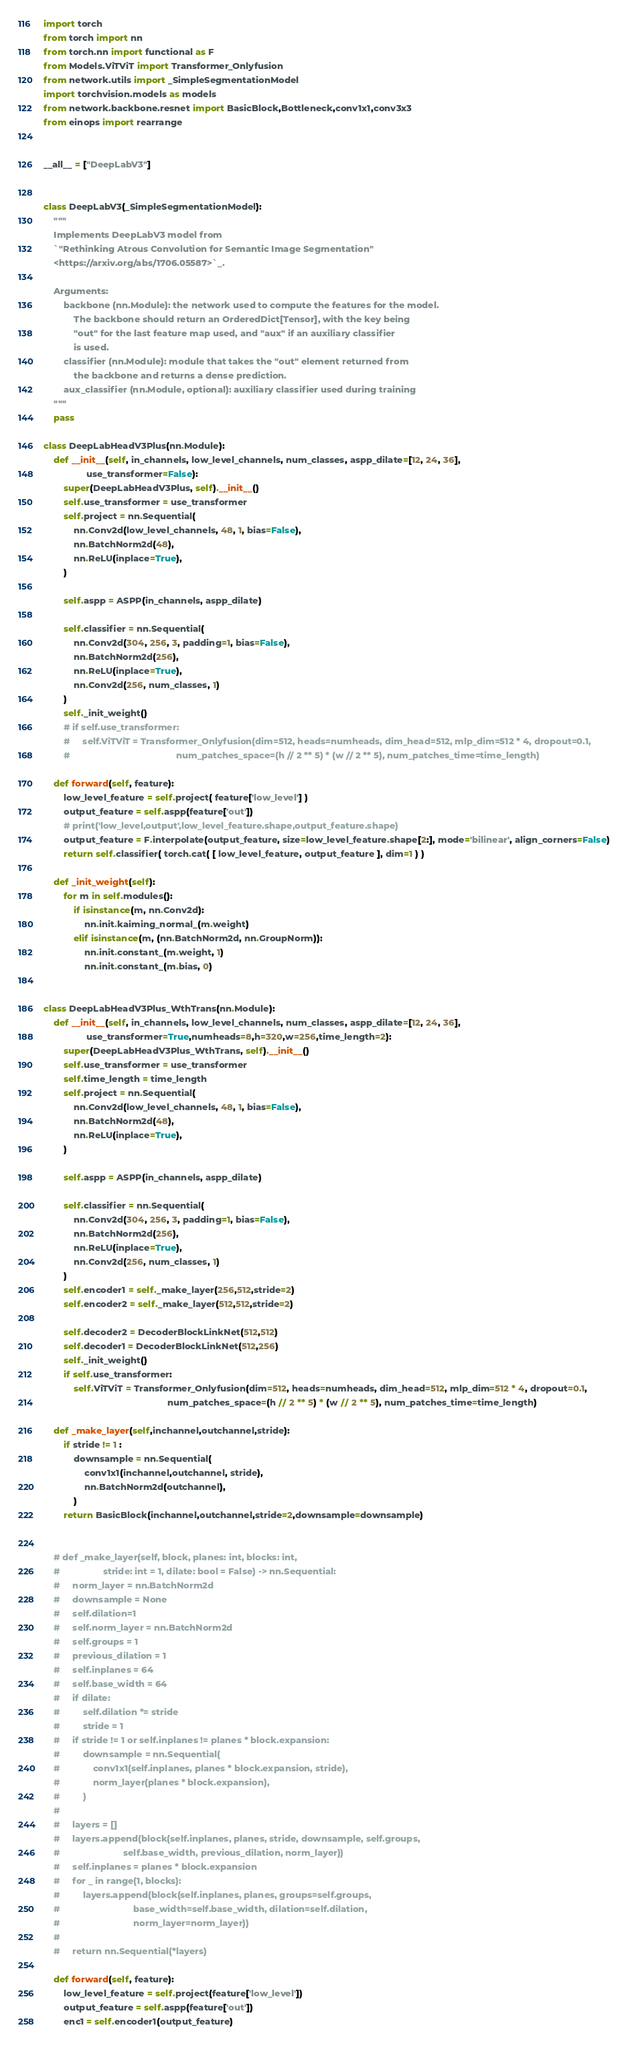Convert code to text. <code><loc_0><loc_0><loc_500><loc_500><_Python_>import torch
from torch import nn
from torch.nn import functional as F
from Models.ViTViT import Transformer_Onlyfusion
from network.utils import _SimpleSegmentationModel
import torchvision.models as models
from network.backbone.resnet import BasicBlock,Bottleneck,conv1x1,conv3x3
from einops import rearrange


__all__ = ["DeepLabV3"]


class DeepLabV3(_SimpleSegmentationModel):
    """
    Implements DeepLabV3 model from
    `"Rethinking Atrous Convolution for Semantic Image Segmentation"
    <https://arxiv.org/abs/1706.05587>`_.

    Arguments:
        backbone (nn.Module): the network used to compute the features for the model.
            The backbone should return an OrderedDict[Tensor], with the key being
            "out" for the last feature map used, and "aux" if an auxiliary classifier
            is used.
        classifier (nn.Module): module that takes the "out" element returned from
            the backbone and returns a dense prediction.
        aux_classifier (nn.Module, optional): auxiliary classifier used during training
    """
    pass

class DeepLabHeadV3Plus(nn.Module):
    def __init__(self, in_channels, low_level_channels, num_classes, aspp_dilate=[12, 24, 36],
                 use_transformer=False):
        super(DeepLabHeadV3Plus, self).__init__()
        self.use_transformer = use_transformer
        self.project = nn.Sequential( 
            nn.Conv2d(low_level_channels, 48, 1, bias=False),
            nn.BatchNorm2d(48),
            nn.ReLU(inplace=True),
        )

        self.aspp = ASPP(in_channels, aspp_dilate)

        self.classifier = nn.Sequential(
            nn.Conv2d(304, 256, 3, padding=1, bias=False),
            nn.BatchNorm2d(256),
            nn.ReLU(inplace=True),
            nn.Conv2d(256, num_classes, 1)
        )
        self._init_weight()
        # if self.use_transformer:
        #     self.ViTViT = Transformer_Onlyfusion(dim=512, heads=numheads, dim_head=512, mlp_dim=512 * 4, dropout=0.1,
        #                                          num_patches_space=(h // 2 ** 5) * (w // 2 ** 5), num_patches_time=time_length)

    def forward(self, feature):
        low_level_feature = self.project( feature['low_level'] )
        output_feature = self.aspp(feature['out'])
        # print('low_level,output',low_level_feature.shape,output_feature.shape)
        output_feature = F.interpolate(output_feature, size=low_level_feature.shape[2:], mode='bilinear', align_corners=False)
        return self.classifier( torch.cat( [ low_level_feature, output_feature ], dim=1 ) )
    
    def _init_weight(self):
        for m in self.modules():
            if isinstance(m, nn.Conv2d):
                nn.init.kaiming_normal_(m.weight)
            elif isinstance(m, (nn.BatchNorm2d, nn.GroupNorm)):
                nn.init.constant_(m.weight, 1)
                nn.init.constant_(m.bias, 0)


class DeepLabHeadV3Plus_WthTrans(nn.Module):
    def __init__(self, in_channels, low_level_channels, num_classes, aspp_dilate=[12, 24, 36],
                 use_transformer=True,numheads=8,h=320,w=256,time_length=2):
        super(DeepLabHeadV3Plus_WthTrans, self).__init__()
        self.use_transformer = use_transformer
        self.time_length = time_length
        self.project = nn.Sequential(
            nn.Conv2d(low_level_channels, 48, 1, bias=False),
            nn.BatchNorm2d(48),
            nn.ReLU(inplace=True),
        )

        self.aspp = ASPP(in_channels, aspp_dilate)

        self.classifier = nn.Sequential(
            nn.Conv2d(304, 256, 3, padding=1, bias=False),
            nn.BatchNorm2d(256),
            nn.ReLU(inplace=True),
            nn.Conv2d(256, num_classes, 1)
        )
        self.encoder1 = self._make_layer(256,512,stride=2)
        self.encoder2 = self._make_layer(512,512,stride=2)

        self.decoder2 = DecoderBlockLinkNet(512,512)
        self.decoder1 = DecoderBlockLinkNet(512,256)
        self._init_weight()
        if self.use_transformer:
            self.ViTViT = Transformer_Onlyfusion(dim=512, heads=numheads, dim_head=512, mlp_dim=512 * 4, dropout=0.1,
                                                 num_patches_space=(h // 2 ** 5) * (w // 2 ** 5), num_patches_time=time_length)

    def _make_layer(self,inchannel,outchannel,stride):
        if stride != 1 :
            downsample = nn.Sequential(
                conv1x1(inchannel,outchannel, stride),
                nn.BatchNorm2d(outchannel),
            )
        return BasicBlock(inchannel,outchannel,stride=2,downsample=downsample)


    # def _make_layer(self, block, planes: int, blocks: int,
    #                 stride: int = 1, dilate: bool = False) -> nn.Sequential:
    #     norm_layer = nn.BatchNorm2d
    #     downsample = None
    #     self.dilation=1
    #     self.norm_layer = nn.BatchNorm2d
    #     self.groups = 1
    #     previous_dilation = 1
    #     self.inplanes = 64
    #     self.base_width = 64
    #     if dilate:
    #         self.dilation *= stride
    #         stride = 1
    #     if stride != 1 or self.inplanes != planes * block.expansion:
    #         downsample = nn.Sequential(
    #             conv1x1(self.inplanes, planes * block.expansion, stride),
    #             norm_layer(planes * block.expansion),
    #         )
    #
    #     layers = []
    #     layers.append(block(self.inplanes, planes, stride, downsample, self.groups,
    #                         self.base_width, previous_dilation, norm_layer))
    #     self.inplanes = planes * block.expansion
    #     for _ in range(1, blocks):
    #         layers.append(block(self.inplanes, planes, groups=self.groups,
    #                             base_width=self.base_width, dilation=self.dilation,
    #                             norm_layer=norm_layer))
    #
    #     return nn.Sequential(*layers)

    def forward(self, feature):
        low_level_feature = self.project(feature['low_level'])
        output_feature = self.aspp(feature['out'])
        enc1 = self.encoder1(output_feature)</code> 